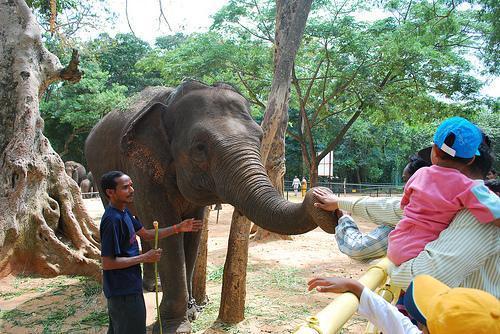How many elephants are there?
Give a very brief answer. 1. 